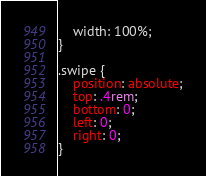<code> <loc_0><loc_0><loc_500><loc_500><_CSS_>    width: 100%;
}

.swipe {
    position: absolute;
    top: .4rem;
    bottom: 0;
    left: 0;
    right: 0;
}</code> 